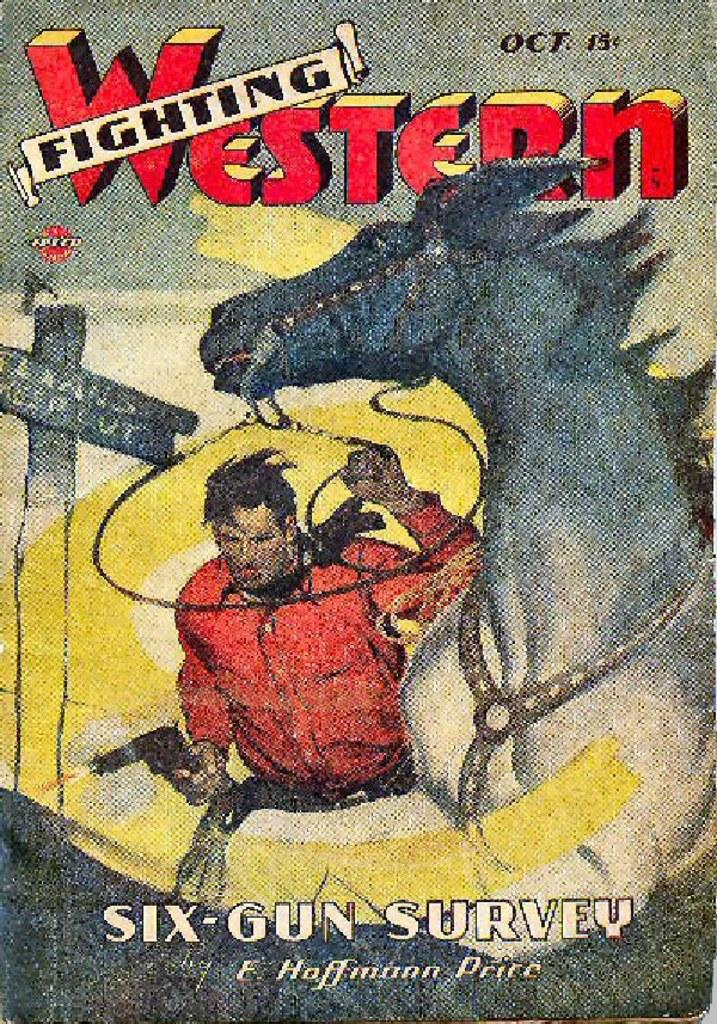<image>
Give a short and clear explanation of the subsequent image. A Western Fighting comic is dated Oct in the upper right corner. 